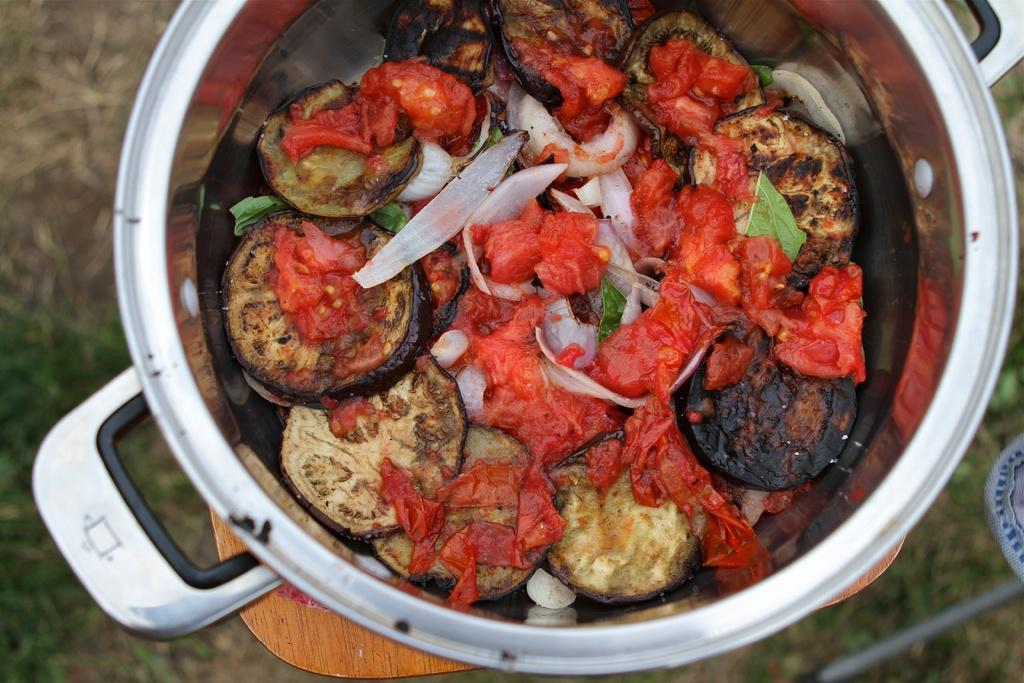What is inside the container that can be seen in the image? There is a container with food items in the image. What can be seen beneath the container in the image? The ground is visible in the image. What type of vegetation is present on the ground? There is grass on the ground. What is located on the right side of the image? There are objects on the right side of the image. What type of poison is present in the image? There is no poison present in the image. 